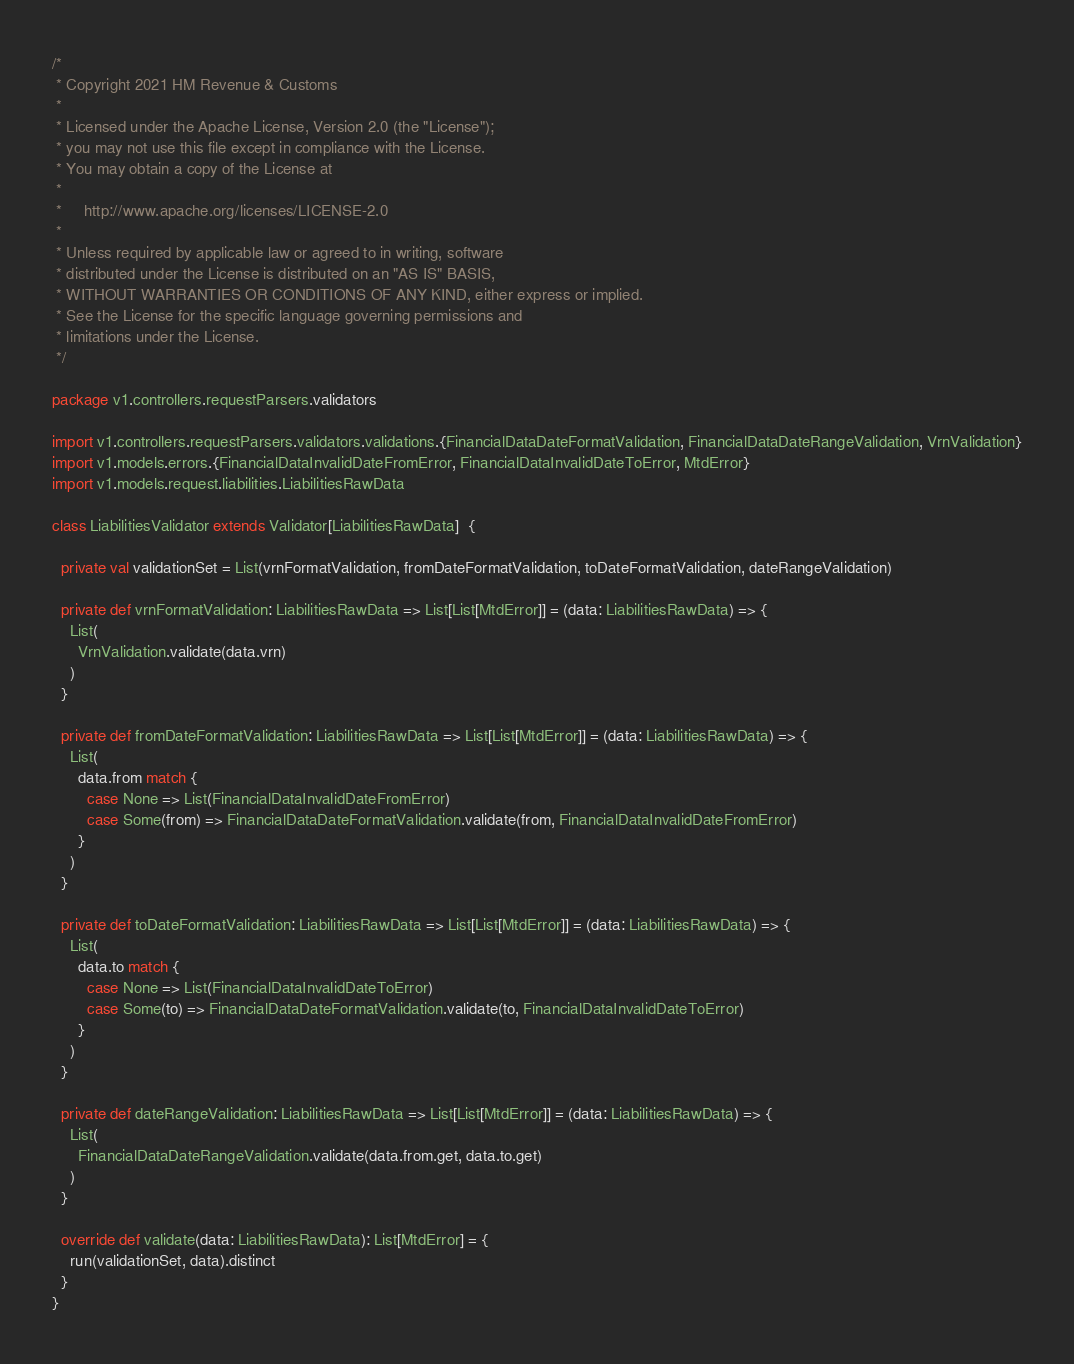<code> <loc_0><loc_0><loc_500><loc_500><_Scala_>/*
 * Copyright 2021 HM Revenue & Customs
 *
 * Licensed under the Apache License, Version 2.0 (the "License");
 * you may not use this file except in compliance with the License.
 * You may obtain a copy of the License at
 *
 *     http://www.apache.org/licenses/LICENSE-2.0
 *
 * Unless required by applicable law or agreed to in writing, software
 * distributed under the License is distributed on an "AS IS" BASIS,
 * WITHOUT WARRANTIES OR CONDITIONS OF ANY KIND, either express or implied.
 * See the License for the specific language governing permissions and
 * limitations under the License.
 */

package v1.controllers.requestParsers.validators

import v1.controllers.requestParsers.validators.validations.{FinancialDataDateFormatValidation, FinancialDataDateRangeValidation, VrnValidation}
import v1.models.errors.{FinancialDataInvalidDateFromError, FinancialDataInvalidDateToError, MtdError}
import v1.models.request.liabilities.LiabilitiesRawData

class LiabilitiesValidator extends Validator[LiabilitiesRawData]  {

  private val validationSet = List(vrnFormatValidation, fromDateFormatValidation, toDateFormatValidation, dateRangeValidation)

  private def vrnFormatValidation: LiabilitiesRawData => List[List[MtdError]] = (data: LiabilitiesRawData) => {
    List(
      VrnValidation.validate(data.vrn)
    )
  }

  private def fromDateFormatValidation: LiabilitiesRawData => List[List[MtdError]] = (data: LiabilitiesRawData) => {
    List(
      data.from match {
        case None => List(FinancialDataInvalidDateFromError)
        case Some(from) => FinancialDataDateFormatValidation.validate(from, FinancialDataInvalidDateFromError)
      }
    )
  }

  private def toDateFormatValidation: LiabilitiesRawData => List[List[MtdError]] = (data: LiabilitiesRawData) => {
    List(
      data.to match {
        case None => List(FinancialDataInvalidDateToError)
        case Some(to) => FinancialDataDateFormatValidation.validate(to, FinancialDataInvalidDateToError)
      }
    )
  }

  private def dateRangeValidation: LiabilitiesRawData => List[List[MtdError]] = (data: LiabilitiesRawData) => {
    List(
      FinancialDataDateRangeValidation.validate(data.from.get, data.to.get)
    )
  }

  override def validate(data: LiabilitiesRawData): List[MtdError] = {
    run(validationSet, data).distinct
  }
}
</code> 